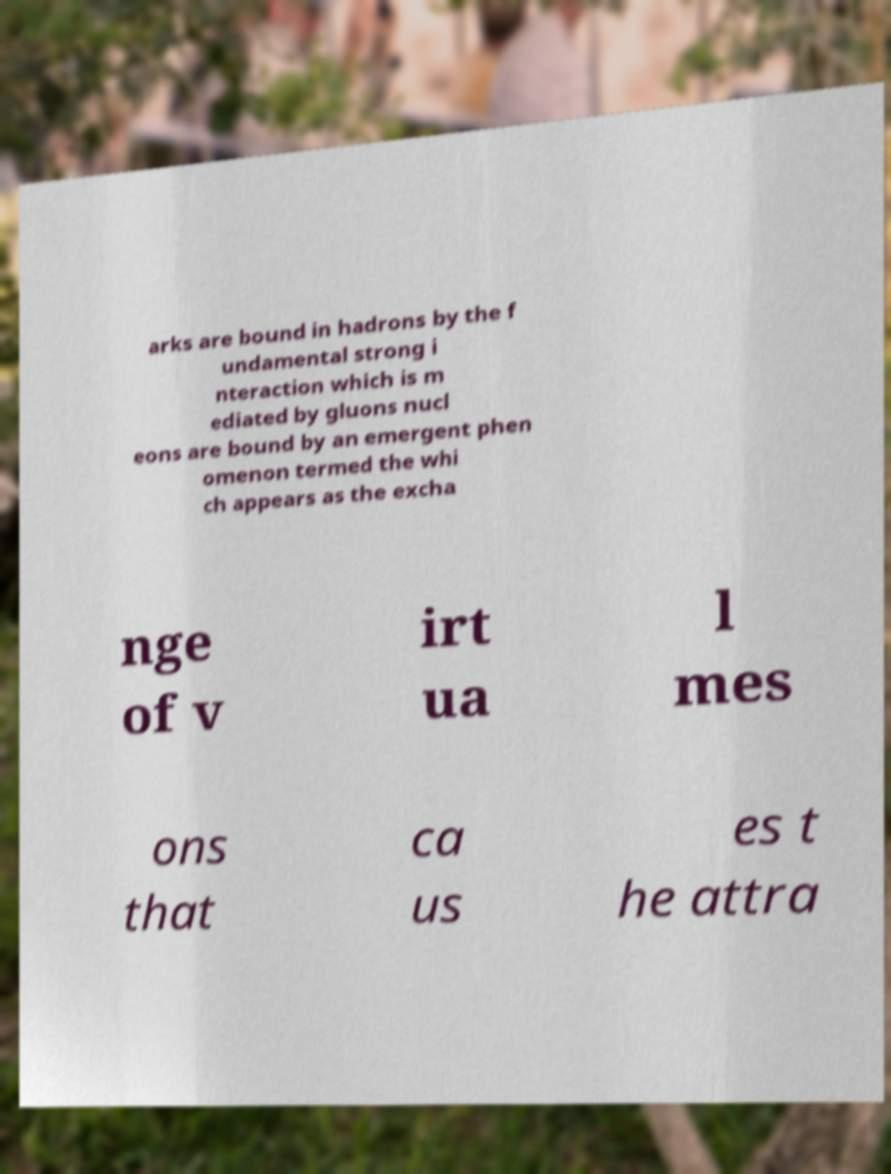For documentation purposes, I need the text within this image transcribed. Could you provide that? arks are bound in hadrons by the f undamental strong i nteraction which is m ediated by gluons nucl eons are bound by an emergent phen omenon termed the whi ch appears as the excha nge of v irt ua l mes ons that ca us es t he attra 